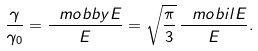Convert formula to latex. <formula><loc_0><loc_0><loc_500><loc_500>\frac { \gamma } { \gamma _ { 0 } } = \frac { \ m o b b y { E } } { E } = \sqrt { \frac { \pi } { 3 } } \, \frac { \ m o b i l { E } } { E } .</formula> 